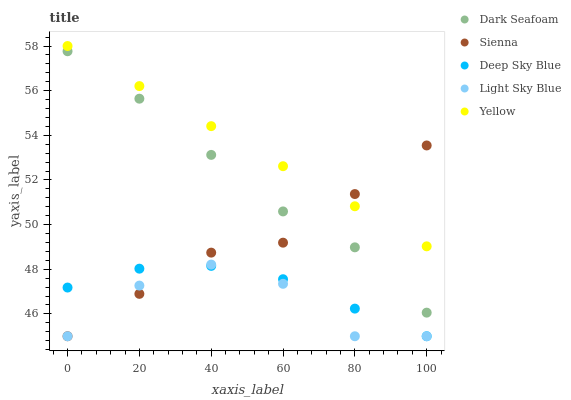Does Light Sky Blue have the minimum area under the curve?
Answer yes or no. Yes. Does Yellow have the maximum area under the curve?
Answer yes or no. Yes. Does Dark Seafoam have the minimum area under the curve?
Answer yes or no. No. Does Dark Seafoam have the maximum area under the curve?
Answer yes or no. No. Is Yellow the smoothest?
Answer yes or no. Yes. Is Light Sky Blue the roughest?
Answer yes or no. Yes. Is Dark Seafoam the smoothest?
Answer yes or no. No. Is Dark Seafoam the roughest?
Answer yes or no. No. Does Sienna have the lowest value?
Answer yes or no. Yes. Does Dark Seafoam have the lowest value?
Answer yes or no. No. Does Yellow have the highest value?
Answer yes or no. Yes. Does Dark Seafoam have the highest value?
Answer yes or no. No. Is Light Sky Blue less than Yellow?
Answer yes or no. Yes. Is Yellow greater than Dark Seafoam?
Answer yes or no. Yes. Does Sienna intersect Dark Seafoam?
Answer yes or no. Yes. Is Sienna less than Dark Seafoam?
Answer yes or no. No. Is Sienna greater than Dark Seafoam?
Answer yes or no. No. Does Light Sky Blue intersect Yellow?
Answer yes or no. No. 